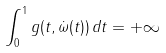<formula> <loc_0><loc_0><loc_500><loc_500>\int _ { 0 } ^ { 1 } g ( t , \dot { \omega } ( t ) ) \, d t = + \infty</formula> 